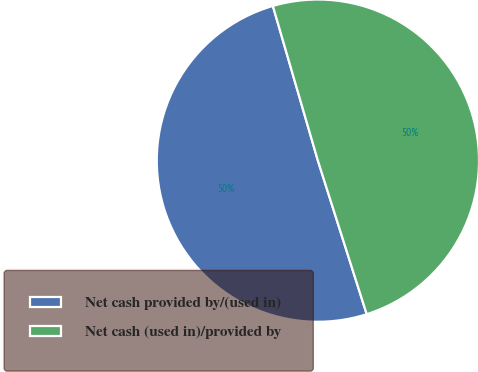Convert chart. <chart><loc_0><loc_0><loc_500><loc_500><pie_chart><fcel>Net cash provided by/(used in)<fcel>Net cash (used in)/provided by<nl><fcel>50.39%<fcel>49.61%<nl></chart> 